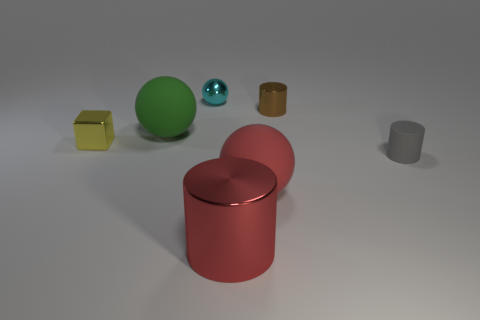Is the color of the big cylinder the same as the big sphere in front of the small block?
Provide a succinct answer. Yes. Is the number of tiny objects to the right of the tiny cyan metallic object the same as the number of cyan balls that are in front of the green sphere?
Offer a very short reply. No. What material is the large sphere that is behind the gray cylinder?
Provide a short and direct response. Rubber. What number of objects are either rubber balls that are on the right side of the cyan metal sphere or tiny purple shiny cylinders?
Give a very brief answer. 1. What number of other things are there of the same shape as the yellow metal thing?
Ensure brevity in your answer.  0. There is a red matte thing that is in front of the yellow metal cube; does it have the same shape as the tiny yellow metallic thing?
Make the answer very short. No. Are there any large spheres behind the gray thing?
Offer a very short reply. Yes. What number of big objects are red metal things or balls?
Ensure brevity in your answer.  3. Are the cyan sphere and the green object made of the same material?
Make the answer very short. No. There is a matte ball that is the same color as the large metallic object; what size is it?
Provide a succinct answer. Large. 